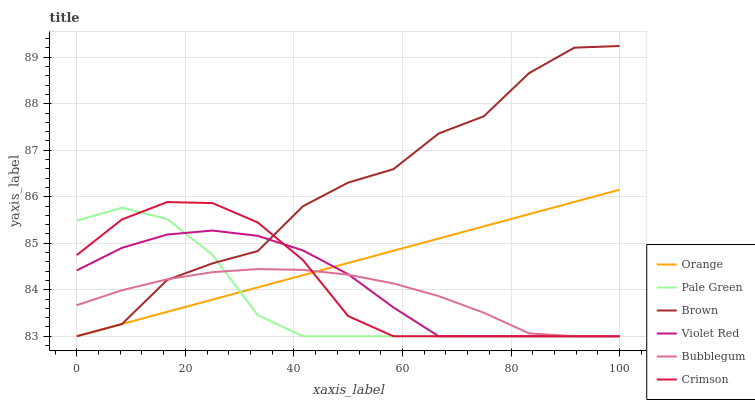Does Pale Green have the minimum area under the curve?
Answer yes or no. Yes. Does Brown have the maximum area under the curve?
Answer yes or no. Yes. Does Violet Red have the minimum area under the curve?
Answer yes or no. No. Does Violet Red have the maximum area under the curve?
Answer yes or no. No. Is Orange the smoothest?
Answer yes or no. Yes. Is Brown the roughest?
Answer yes or no. Yes. Is Violet Red the smoothest?
Answer yes or no. No. Is Violet Red the roughest?
Answer yes or no. No. Does Brown have the lowest value?
Answer yes or no. Yes. Does Brown have the highest value?
Answer yes or no. Yes. Does Violet Red have the highest value?
Answer yes or no. No. Does Brown intersect Violet Red?
Answer yes or no. Yes. Is Brown less than Violet Red?
Answer yes or no. No. Is Brown greater than Violet Red?
Answer yes or no. No. 